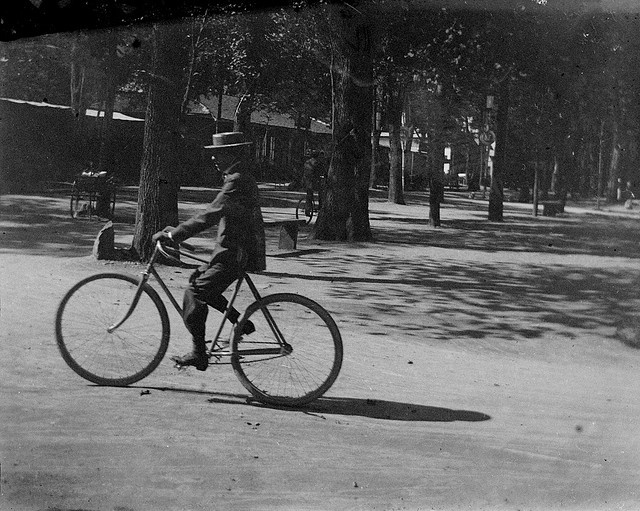Describe the objects in this image and their specific colors. I can see bicycle in black, darkgray, gray, and lightgray tones, people in black, gray, and lightgray tones, bicycle in black, darkgray, gray, and lightgray tones, bench in black, gray, and darkgray tones, and bicycle in black, darkgray, gray, and lightgray tones in this image. 